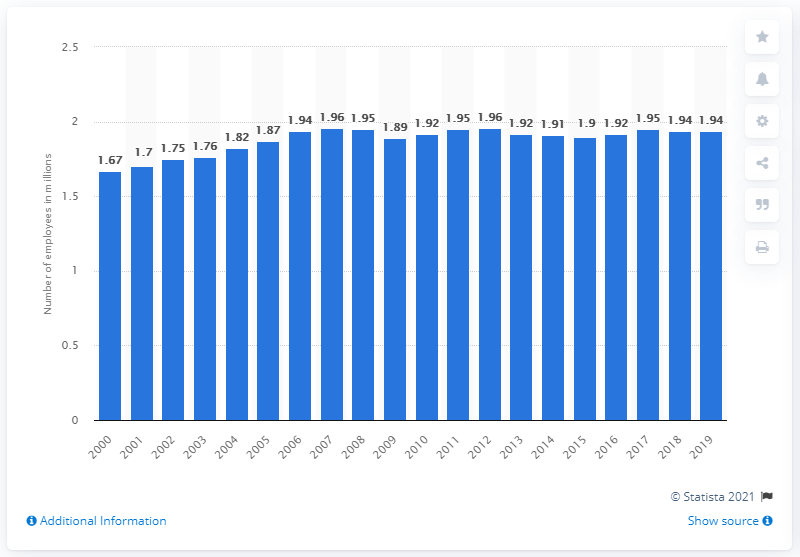Draw attention to some important aspects in this diagram. In 2019, there were 1.94 employees of FDIC-insured commercial banks. In 2019, there were approximately 1.94 million employees working for FDIC-insured commercial banks in the United States. 